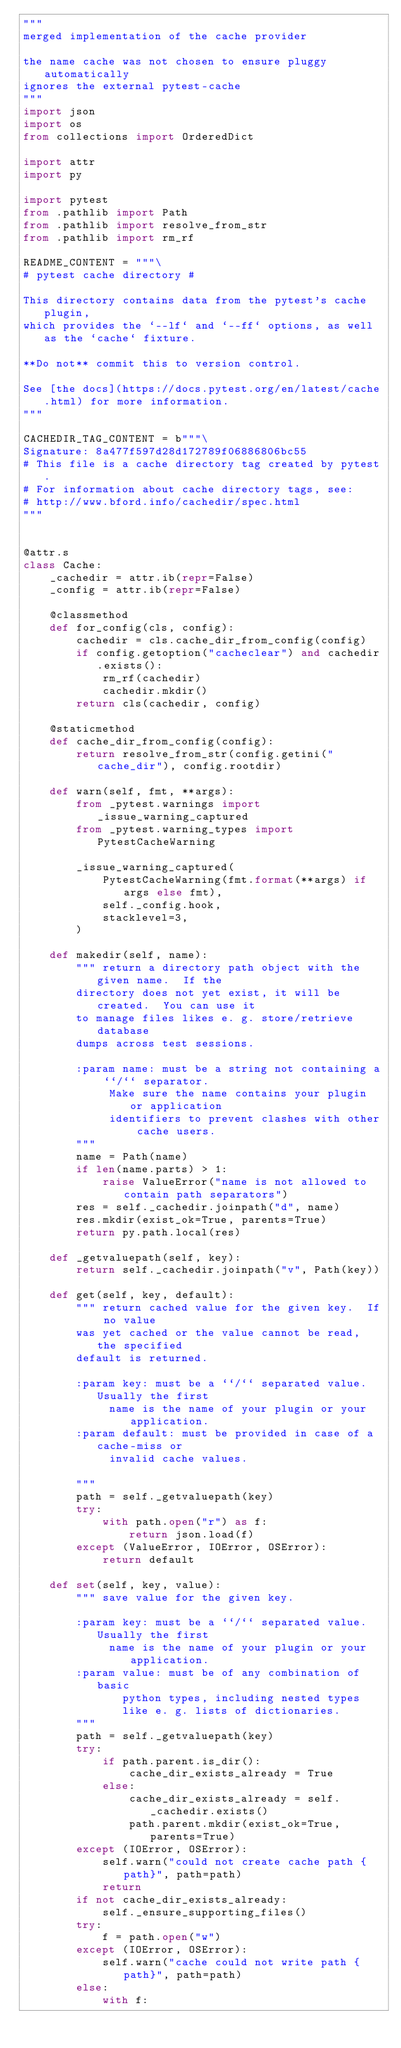Convert code to text. <code><loc_0><loc_0><loc_500><loc_500><_Python_>"""
merged implementation of the cache provider

the name cache was not chosen to ensure pluggy automatically
ignores the external pytest-cache
"""
import json
import os
from collections import OrderedDict

import attr
import py

import pytest
from .pathlib import Path
from .pathlib import resolve_from_str
from .pathlib import rm_rf

README_CONTENT = """\
# pytest cache directory #

This directory contains data from the pytest's cache plugin,
which provides the `--lf` and `--ff` options, as well as the `cache` fixture.

**Do not** commit this to version control.

See [the docs](https://docs.pytest.org/en/latest/cache.html) for more information.
"""

CACHEDIR_TAG_CONTENT = b"""\
Signature: 8a477f597d28d172789f06886806bc55
# This file is a cache directory tag created by pytest.
# For information about cache directory tags, see:
#	http://www.bford.info/cachedir/spec.html
"""


@attr.s
class Cache:
    _cachedir = attr.ib(repr=False)
    _config = attr.ib(repr=False)

    @classmethod
    def for_config(cls, config):
        cachedir = cls.cache_dir_from_config(config)
        if config.getoption("cacheclear") and cachedir.exists():
            rm_rf(cachedir)
            cachedir.mkdir()
        return cls(cachedir, config)

    @staticmethod
    def cache_dir_from_config(config):
        return resolve_from_str(config.getini("cache_dir"), config.rootdir)

    def warn(self, fmt, **args):
        from _pytest.warnings import _issue_warning_captured
        from _pytest.warning_types import PytestCacheWarning

        _issue_warning_captured(
            PytestCacheWarning(fmt.format(**args) if args else fmt),
            self._config.hook,
            stacklevel=3,
        )

    def makedir(self, name):
        """ return a directory path object with the given name.  If the
        directory does not yet exist, it will be created.  You can use it
        to manage files likes e. g. store/retrieve database
        dumps across test sessions.

        :param name: must be a string not containing a ``/`` separator.
             Make sure the name contains your plugin or application
             identifiers to prevent clashes with other cache users.
        """
        name = Path(name)
        if len(name.parts) > 1:
            raise ValueError("name is not allowed to contain path separators")
        res = self._cachedir.joinpath("d", name)
        res.mkdir(exist_ok=True, parents=True)
        return py.path.local(res)

    def _getvaluepath(self, key):
        return self._cachedir.joinpath("v", Path(key))

    def get(self, key, default):
        """ return cached value for the given key.  If no value
        was yet cached or the value cannot be read, the specified
        default is returned.

        :param key: must be a ``/`` separated value. Usually the first
             name is the name of your plugin or your application.
        :param default: must be provided in case of a cache-miss or
             invalid cache values.

        """
        path = self._getvaluepath(key)
        try:
            with path.open("r") as f:
                return json.load(f)
        except (ValueError, IOError, OSError):
            return default

    def set(self, key, value):
        """ save value for the given key.

        :param key: must be a ``/`` separated value. Usually the first
             name is the name of your plugin or your application.
        :param value: must be of any combination of basic
               python types, including nested types
               like e. g. lists of dictionaries.
        """
        path = self._getvaluepath(key)
        try:
            if path.parent.is_dir():
                cache_dir_exists_already = True
            else:
                cache_dir_exists_already = self._cachedir.exists()
                path.parent.mkdir(exist_ok=True, parents=True)
        except (IOError, OSError):
            self.warn("could not create cache path {path}", path=path)
            return
        if not cache_dir_exists_already:
            self._ensure_supporting_files()
        try:
            f = path.open("w")
        except (IOError, OSError):
            self.warn("cache could not write path {path}", path=path)
        else:
            with f:</code> 